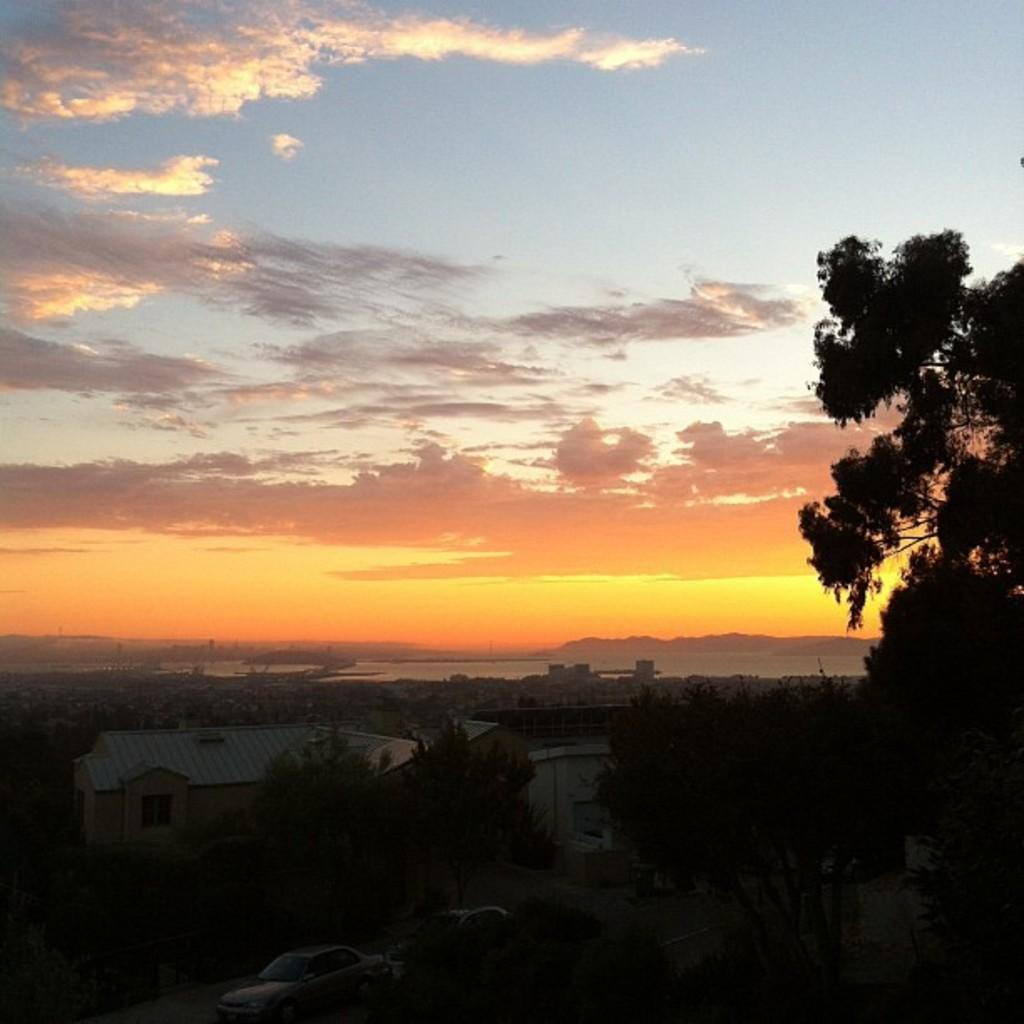What types of man-made structures can be seen in the image? There are buildings in the image. What natural elements are present in the image? There are trees and mountains in the image. What types of vehicles can be seen in the image? There are vehicles in the image. What is visible in the background of the image? The sky is visible in the background of the image. What can be observed in the sky? Clouds are present in the sky. Can you tell me how many ants are crawling on the power lines in the image? There are no ants or power lines present in the image. What type of mitten is being used to climb the mountain in the image? There is no mitten or mountain climbing activity depicted in the image. 